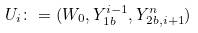<formula> <loc_0><loc_0><loc_500><loc_500>U _ { i } \colon = ( W _ { 0 } , Y _ { 1 b } ^ { i - 1 } , Y _ { 2 b , i + 1 } ^ { n } )</formula> 